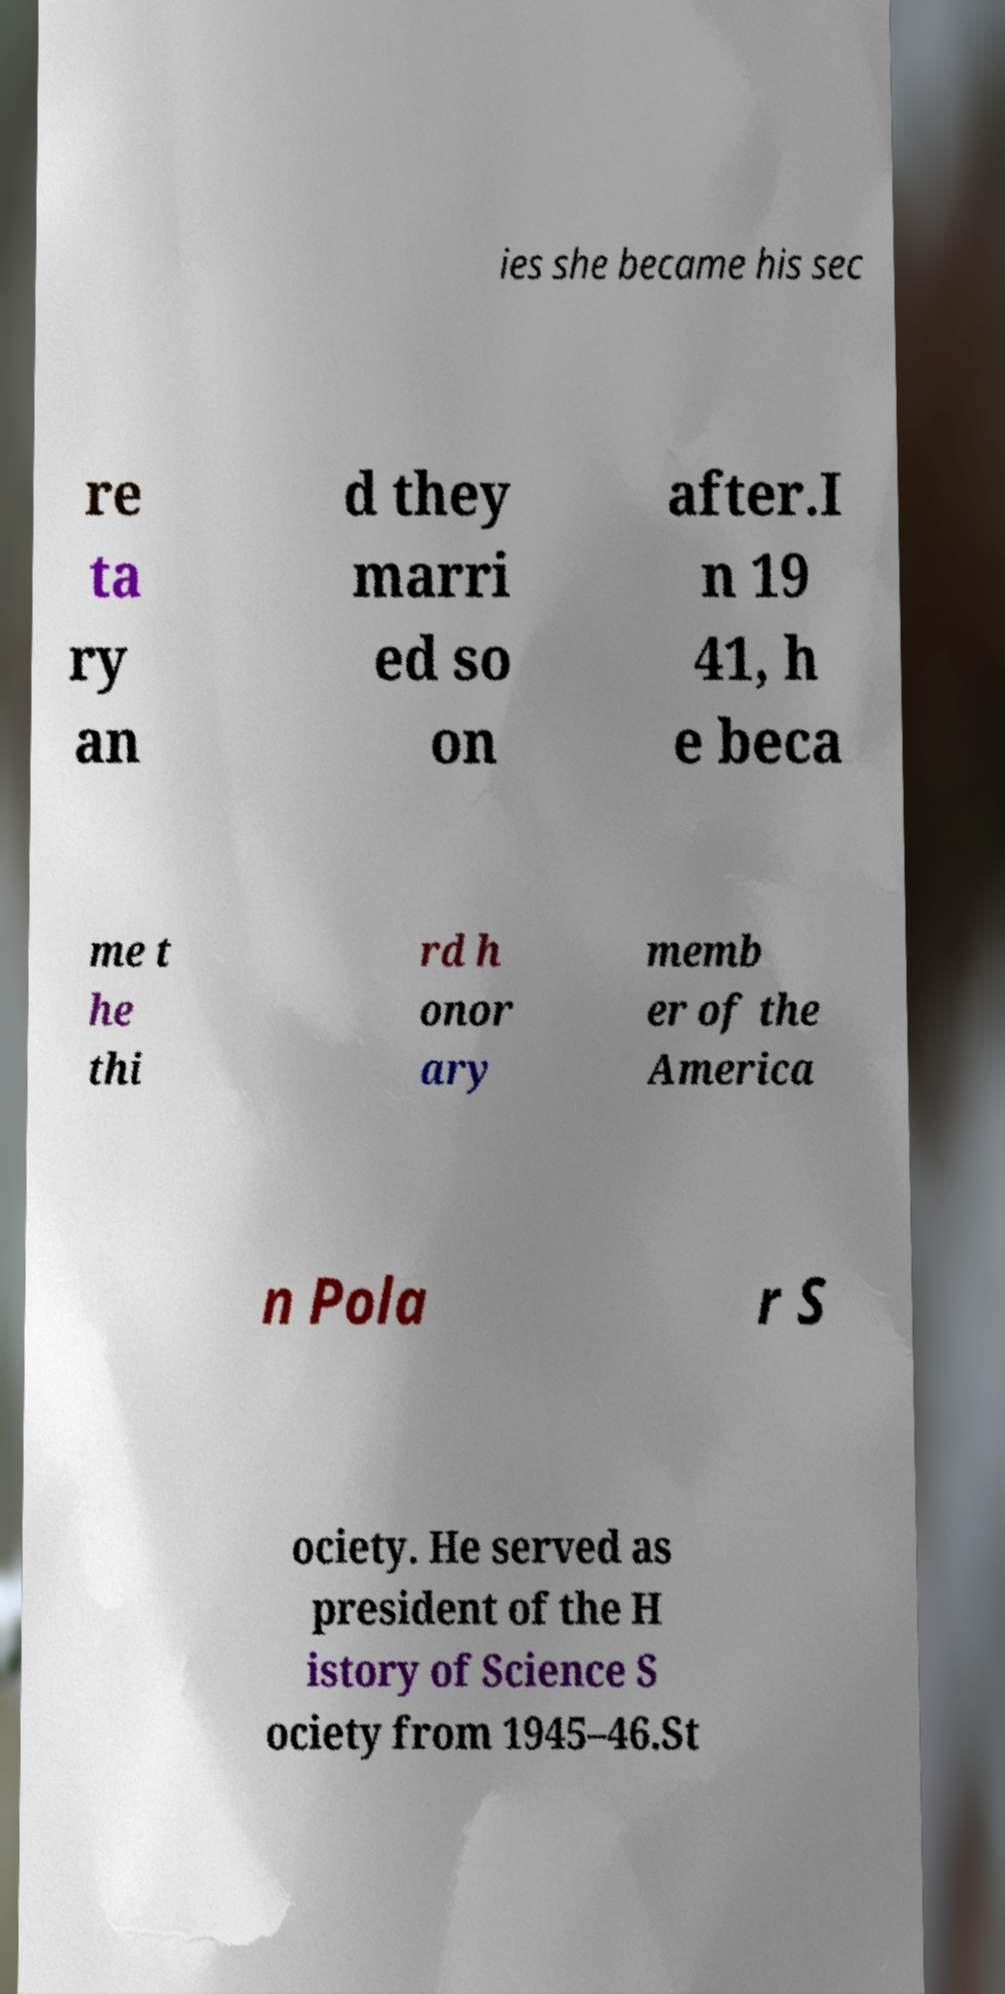For documentation purposes, I need the text within this image transcribed. Could you provide that? ies she became his sec re ta ry an d they marri ed so on after.I n 19 41, h e beca me t he thi rd h onor ary memb er of the America n Pola r S ociety. He served as president of the H istory of Science S ociety from 1945–46.St 